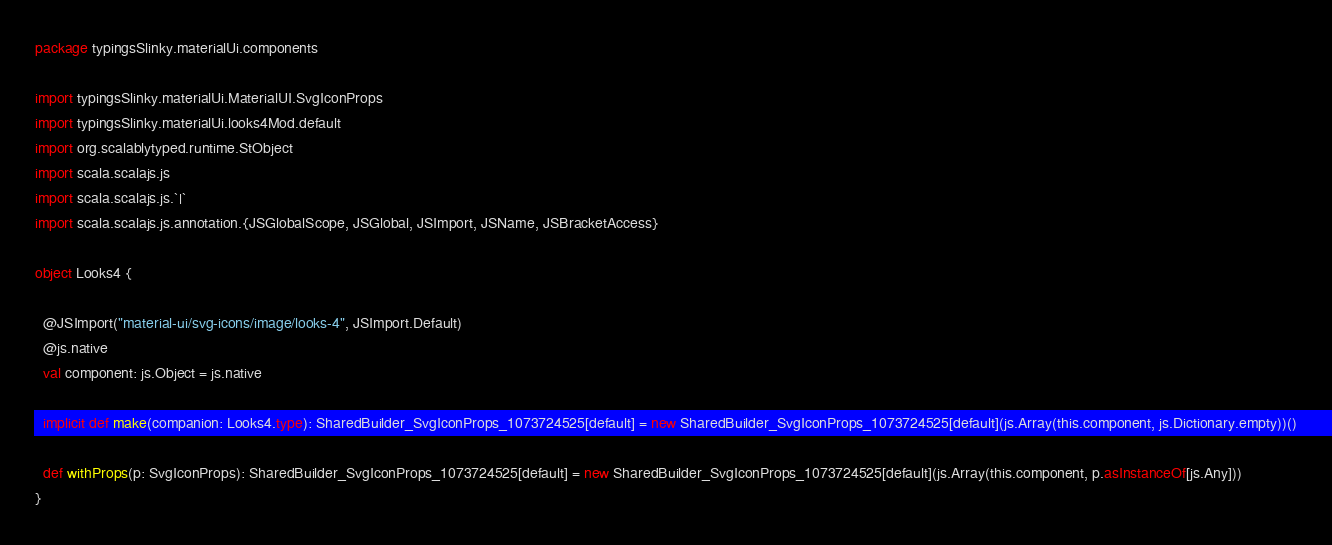<code> <loc_0><loc_0><loc_500><loc_500><_Scala_>package typingsSlinky.materialUi.components

import typingsSlinky.materialUi.MaterialUI.SvgIconProps
import typingsSlinky.materialUi.looks4Mod.default
import org.scalablytyped.runtime.StObject
import scala.scalajs.js
import scala.scalajs.js.`|`
import scala.scalajs.js.annotation.{JSGlobalScope, JSGlobal, JSImport, JSName, JSBracketAccess}

object Looks4 {
  
  @JSImport("material-ui/svg-icons/image/looks-4", JSImport.Default)
  @js.native
  val component: js.Object = js.native
  
  implicit def make(companion: Looks4.type): SharedBuilder_SvgIconProps_1073724525[default] = new SharedBuilder_SvgIconProps_1073724525[default](js.Array(this.component, js.Dictionary.empty))()
  
  def withProps(p: SvgIconProps): SharedBuilder_SvgIconProps_1073724525[default] = new SharedBuilder_SvgIconProps_1073724525[default](js.Array(this.component, p.asInstanceOf[js.Any]))
}
</code> 